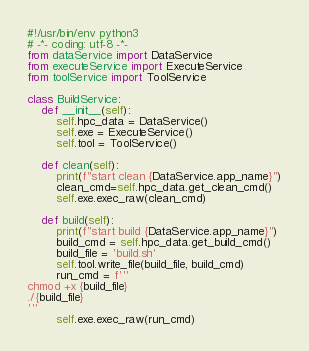Convert code to text. <code><loc_0><loc_0><loc_500><loc_500><_Python_>#!/usr/bin/env python3
# -*- coding: utf-8 -*- 
from dataService import DataService
from executeService import ExecuteService
from toolService import ToolService

class BuildService:
    def __init__(self):
        self.hpc_data = DataService()
        self.exe = ExecuteService()
        self.tool = ToolService()

    def clean(self):
        print(f"start clean {DataService.app_name}")
        clean_cmd=self.hpc_data.get_clean_cmd()
        self.exe.exec_raw(clean_cmd)

    def build(self):
        print(f"start build {DataService.app_name}")
        build_cmd = self.hpc_data.get_build_cmd()
        build_file = 'build.sh'
        self.tool.write_file(build_file, build_cmd)
        run_cmd = f'''
chmod +x {build_file}
./{build_file}
'''
        self.exe.exec_raw(run_cmd)
</code> 